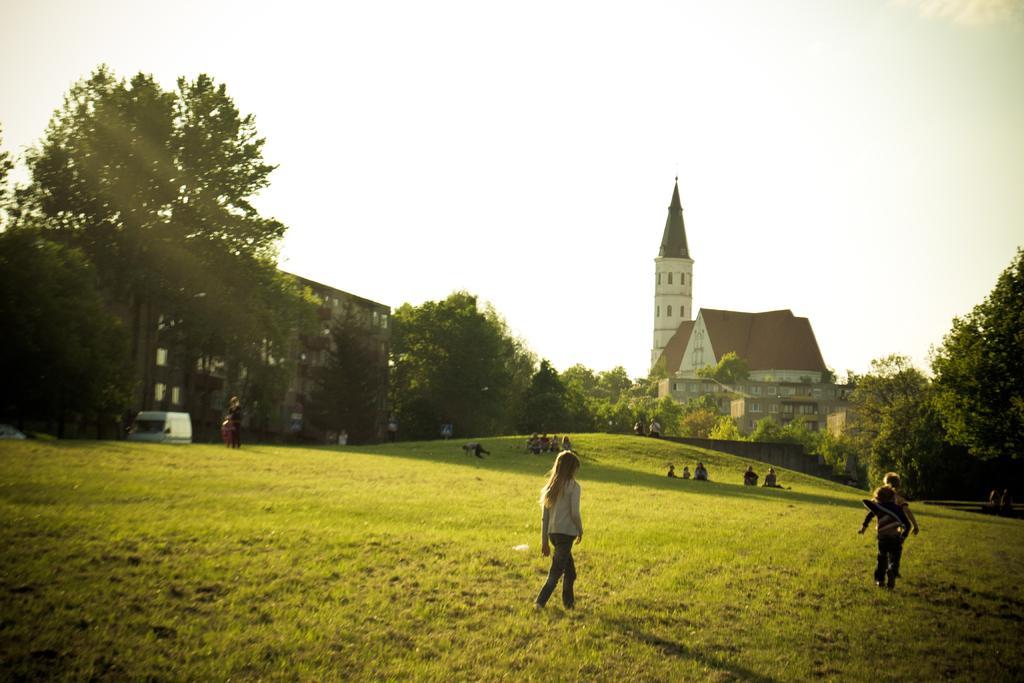How would you summarize this image in a sentence or two? In this image I can see group of people, some are sitting and some are standing. In front the person is wearing white color shirt. In the background I can see few trees in green color, buildings in white and brown color and the sky is in white color. 